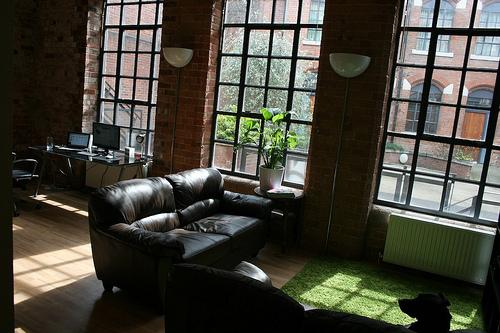What objects are placed on the desk? A monitor and a laptop are placed on the desk. What kind of animal is present in the picture and what is it doing? A dog is present in the picture, sitting on a black leather sofa. How many lamps are there in the room and what are their specific locations? There are two lamps in the room; one is hanging from the ceiling near the desk, and the other is also hanging from the ceiling near the window. In the context of the image, provide a brief summary of the computer equipment and their locations. There is a desktop computer with a monitor on a desk, a laptop next to the monitor, and a computer chair near the desk. Analyze the interactions between the dog and its surrounding objects. The dog is sitting on the black leather sofa and looking towards the floor. Count the total number of chairs in the room. There is one chair in the room. Identify the types of plants in the room and provide their approximate locations. There is a green plant in a white pot near the window and another large green plant in front of the window. What type of heater is in the room and where is it located? A white colored radiator heater is against the wall, under a window. Identify the piece of furniture next to the white pot and describe its type and color. A black leather sofa is next to the white pot. Describe the type, color, and placement of the rug in the image. There is a green rug on the floor, placed in front of the black leather sofa. 